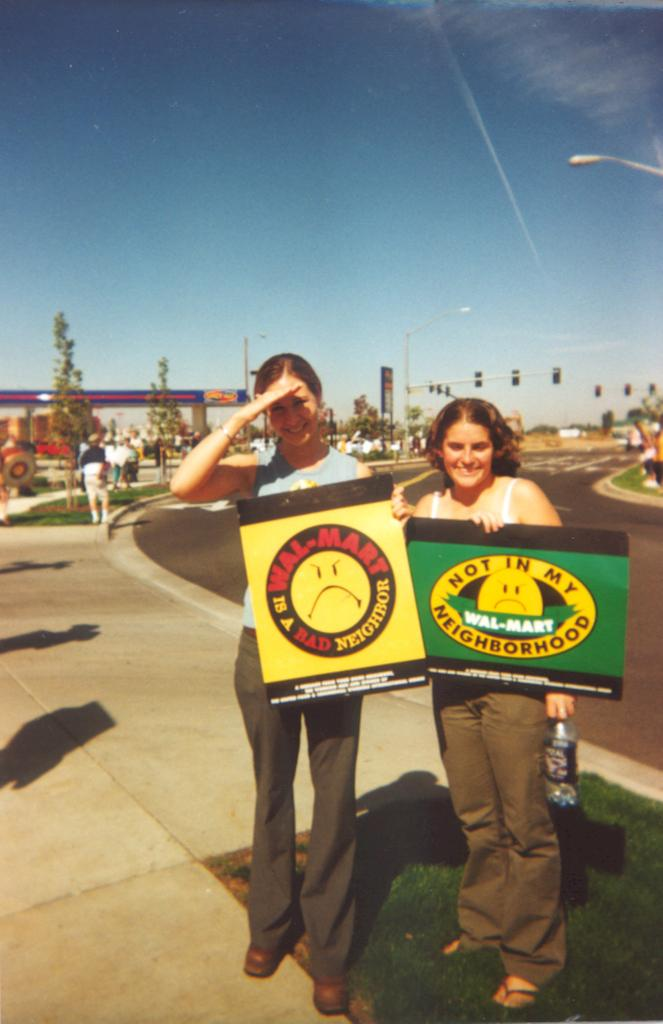How many people are in the image? There are two women in the image. What are the women holding in the image? The women are holding a board with text written on it. What can be seen on the right side of the image? There is a road on the right side of the image. What is visible in the background of the image? The sky is visible in the background of the image. What type of powder is being used by the dog in the image? There is no dog present in the image, and therefore no powder can be observed. 